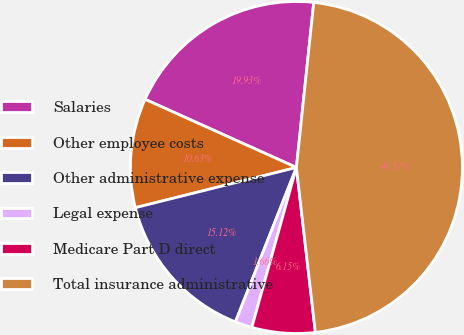Convert chart to OTSL. <chart><loc_0><loc_0><loc_500><loc_500><pie_chart><fcel>Salaries<fcel>Other employee costs<fcel>Other administrative expense<fcel>Legal expense<fcel>Medicare Part D direct<fcel>Total insurance administrative<nl><fcel>19.93%<fcel>10.63%<fcel>15.12%<fcel>1.66%<fcel>6.15%<fcel>46.51%<nl></chart> 